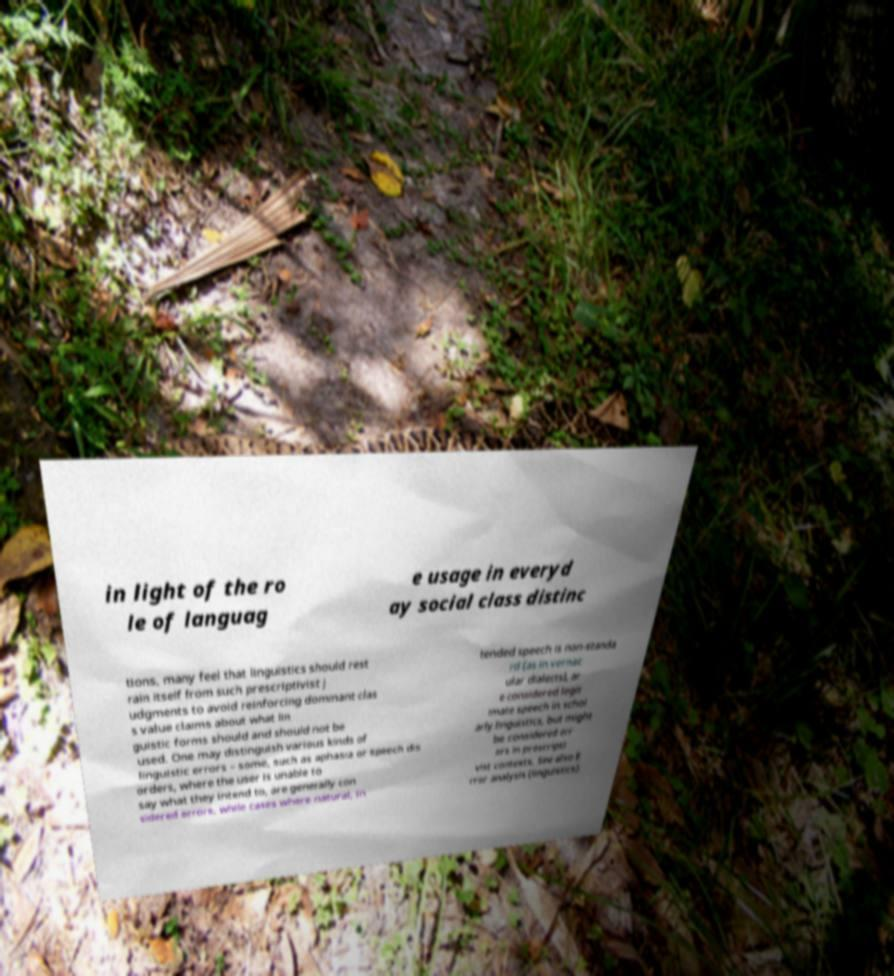For documentation purposes, I need the text within this image transcribed. Could you provide that? in light of the ro le of languag e usage in everyd ay social class distinc tions, many feel that linguistics should rest rain itself from such prescriptivist j udgments to avoid reinforcing dominant clas s value claims about what lin guistic forms should and should not be used. One may distinguish various kinds of linguistic errors – some, such as aphasia or speech dis orders, where the user is unable to say what they intend to, are generally con sidered errors, while cases where natural, in tended speech is non-standa rd (as in vernac ular dialects), ar e considered legit imate speech in schol arly linguistics, but might be considered err ors in prescripti vist contexts. See also E rror analysis (linguistics). 